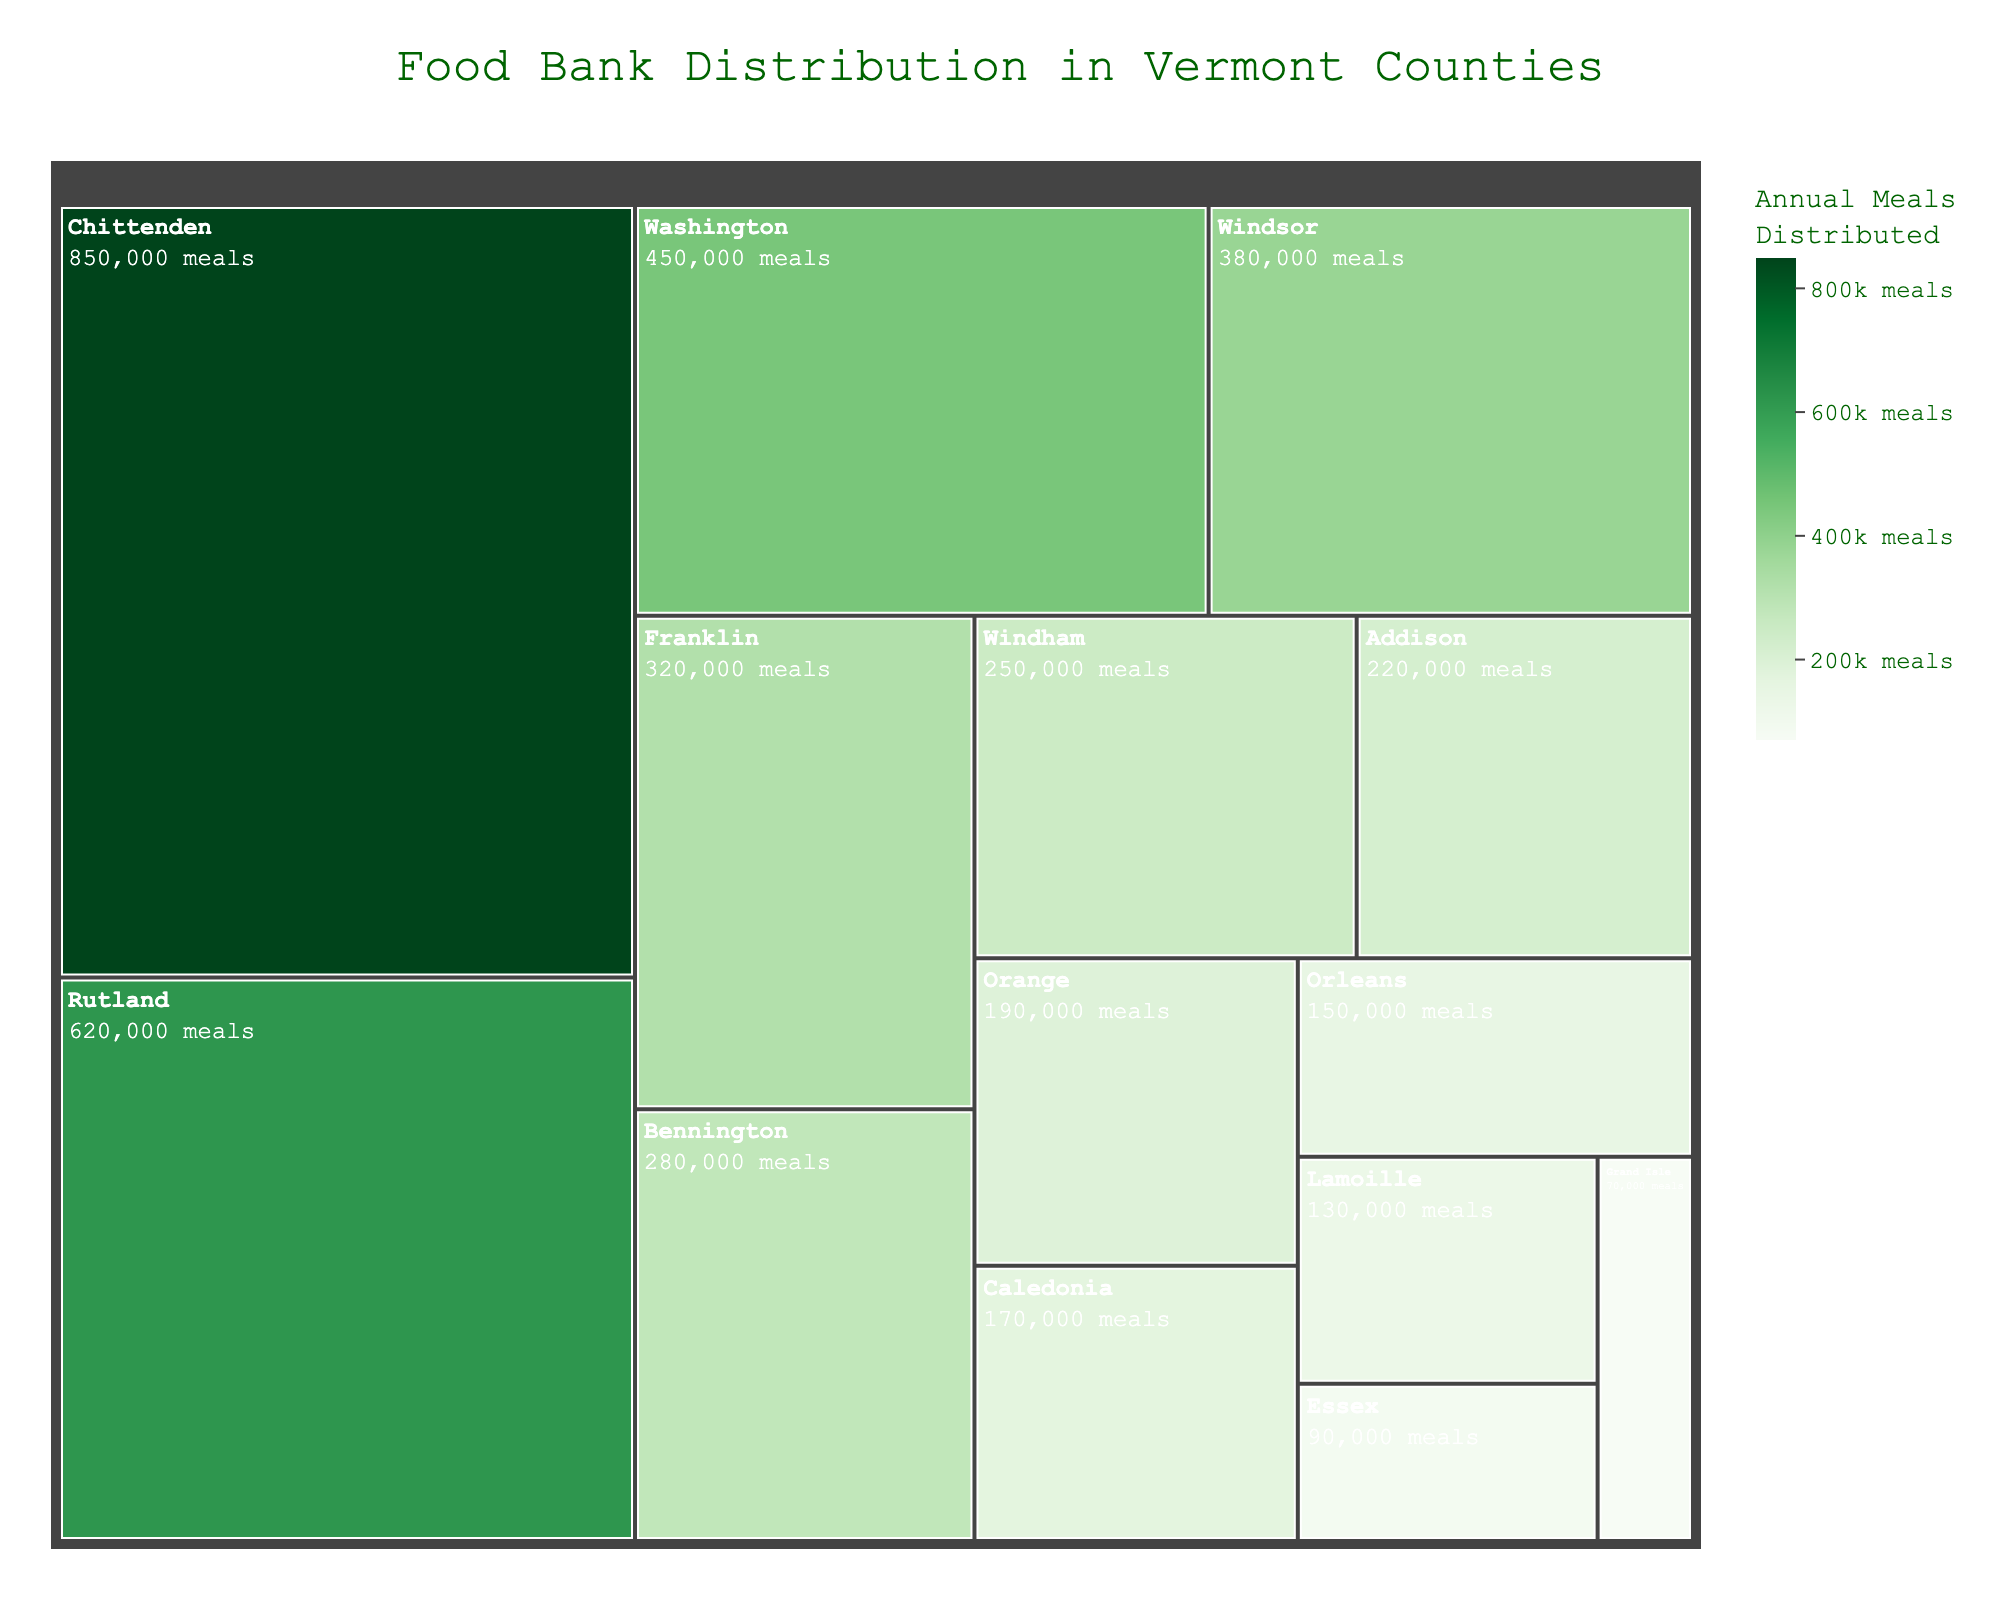What's the total number of annual meals distributed by food banks in Vermont? To find the total number of annual meals distributed, add up the values from all the counties: 850,000 + 620,000 + 450,000 + 380,000 + 320,000 + 280,000 + 250,000 + 220,000 + 190,000 + 170,000 + 150,000 + 130,000 + 90,000 + 70,000 = 4,170,000 meals
Answer: 4,170,000 Which county distributes the largest number of annual meals? Look at the Treemap and identify the county with the largest colored tile, which represents the highest value. Chittenden has the largest tile with 850,000 meals.
Answer: Chittenden Which food bank distributes the least number of annual meals, and in which county is it located? Look for the smallest tile in the Treemap and check the hover data. The smallest tile is for Grand Isle County Food Shelf located in Grand Isle, distributing 70,000 meals annually.
Answer: Grand Isle County Food Shelf in Grand Isle How many more meals does Vermont Foodbank - Barre distribute compared to Upper Valley Haven? Subtract the number of meals distributed by Upper Valley Haven from the meals distributed by Vermont Foodbank - Barre: 850,000 - 380,000 = 470,000 meals
Answer: 470,000 What is the color range of the Annual Meals Distributed scale? Observe the scale bar on the Treemap, which shows a color-graded range. The color range varies from lighter to darker shades of green, indicating increasing values.
Answer: Light green to dark green What's the average number of annual meals distributed across all food banks in Vermont? First, find the total number of meals distributed (4,170,000) and then divide by the number of food banks (14): 4,170,000 / 14 ≈ 297,857 meals
Answer: 297,857 Identify the counties distributing less than 150,000 annual meals. Check the Treemap for counties with values under 150,000. Essex (90,000) and Grand Isle (70,000) distribute less than 150,000 meals annually.
Answer: Essex and Grand Isle How does the number of meals distributed by Central Vermont Community Action Council compare to that of Kitchen Cupboard? Compare the values from the Treemap: Central Vermont Community Action Council distributes 450,000 meals, while Kitchen Cupboard distributes 280,000 meals. Central Vermont Community Action Council distributes 170,000 more meals.
Answer: 170,000 more meals What's the median number of annual meals distributed by the food banks? Order all the meal distribution values and find the middle number: 70,000, 90,000, 130,000, 150,000, 170,000, 190,000, 220,000, 250,000, 280,000, 320,000, 380,000, 450,000, 620,000, 850,000. The median value is 250,000 meals.
Answer: 250,000 How does the meal distribution of HOPE (Helping Overcome Poverty's Effects) differ from the median value for all food banks? HOPE distributes 220,000 meals; the median value is 250,000 meals. The difference is 250,000 - 220,000 = 30,000 fewer meals.
Answer: 30,000 fewer meals 